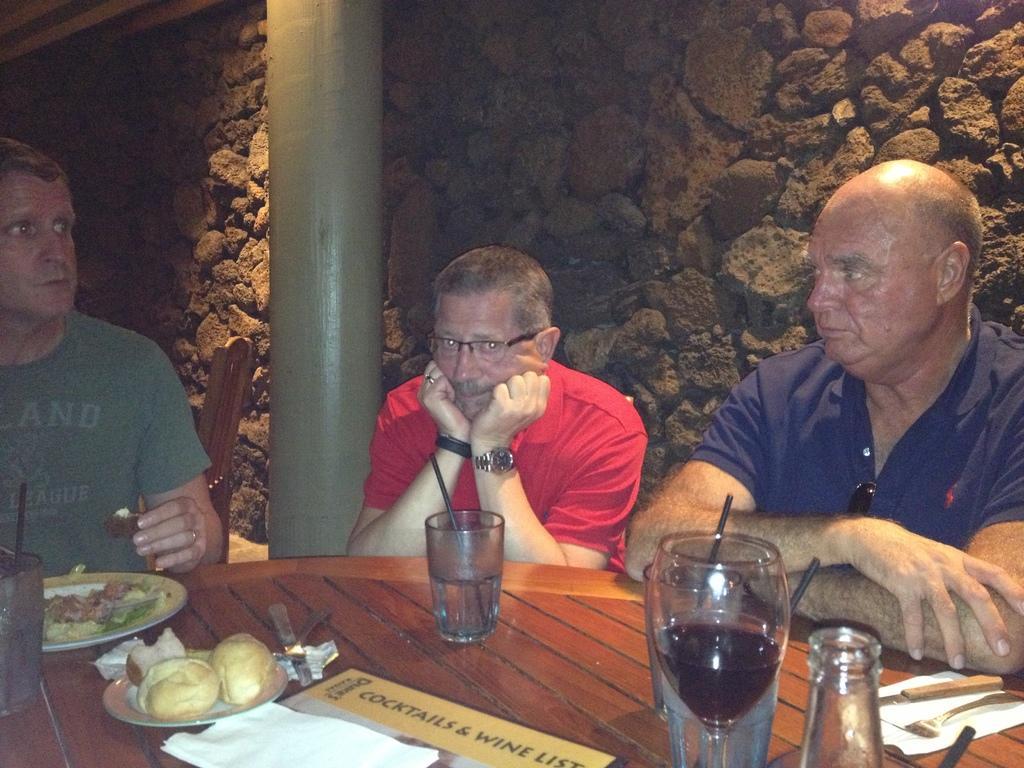Describe this image in one or two sentences. In this image we can see three persons. One person is wearing specs and watch. In front of them there is a wooden surface. On that there are glasses, plates with food items, forks, knives and few other things. In the back there is a pillar and there is a wall with stones. 